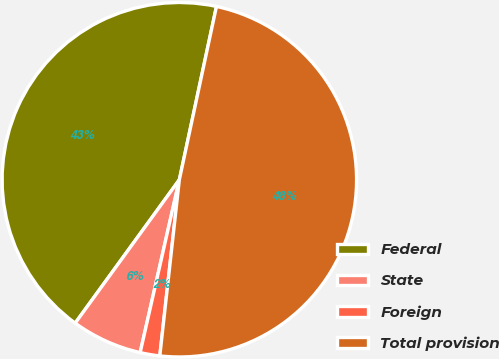Convert chart to OTSL. <chart><loc_0><loc_0><loc_500><loc_500><pie_chart><fcel>Federal<fcel>State<fcel>Foreign<fcel>Total provision<nl><fcel>43.36%<fcel>6.45%<fcel>1.79%<fcel>48.4%<nl></chart> 